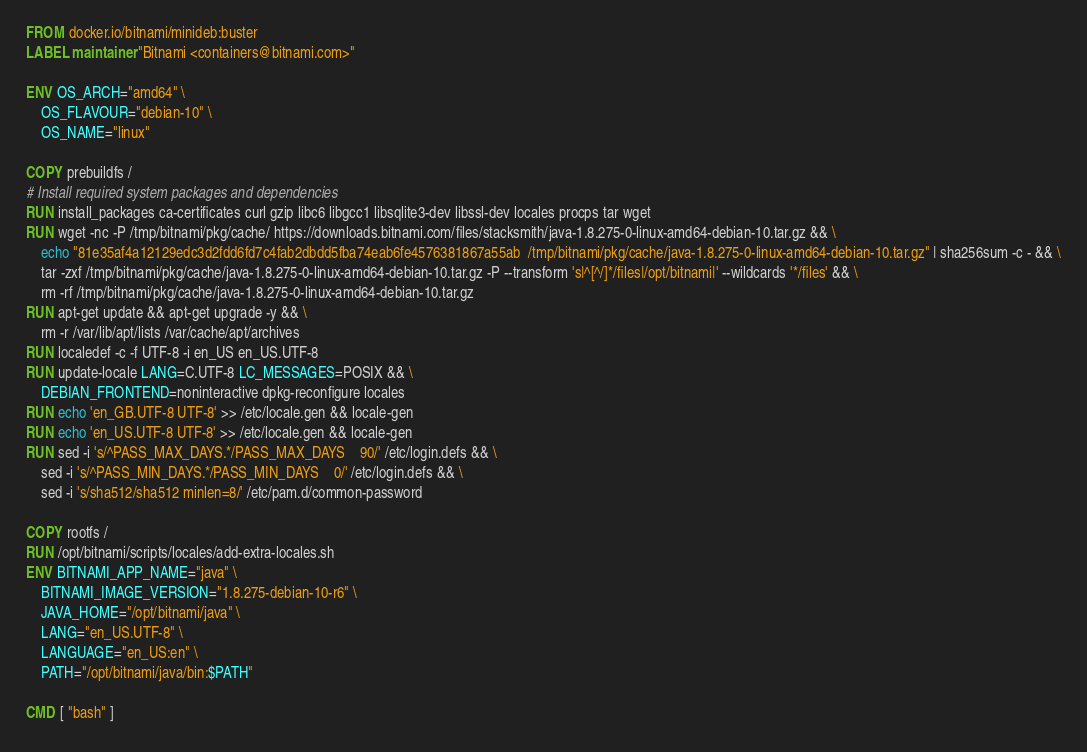<code> <loc_0><loc_0><loc_500><loc_500><_Dockerfile_>FROM docker.io/bitnami/minideb:buster
LABEL maintainer "Bitnami <containers@bitnami.com>"

ENV OS_ARCH="amd64" \
    OS_FLAVOUR="debian-10" \
    OS_NAME="linux"

COPY prebuildfs /
# Install required system packages and dependencies
RUN install_packages ca-certificates curl gzip libc6 libgcc1 libsqlite3-dev libssl-dev locales procps tar wget
RUN wget -nc -P /tmp/bitnami/pkg/cache/ https://downloads.bitnami.com/files/stacksmith/java-1.8.275-0-linux-amd64-debian-10.tar.gz && \
    echo "81e35af4a12129edc3d2fdd6fd7c4fab2dbdd5fba74eab6fe4576381867a55ab  /tmp/bitnami/pkg/cache/java-1.8.275-0-linux-amd64-debian-10.tar.gz" | sha256sum -c - && \
    tar -zxf /tmp/bitnami/pkg/cache/java-1.8.275-0-linux-amd64-debian-10.tar.gz -P --transform 's|^[^/]*/files|/opt/bitnami|' --wildcards '*/files' && \
    rm -rf /tmp/bitnami/pkg/cache/java-1.8.275-0-linux-amd64-debian-10.tar.gz
RUN apt-get update && apt-get upgrade -y && \
    rm -r /var/lib/apt/lists /var/cache/apt/archives
RUN localedef -c -f UTF-8 -i en_US en_US.UTF-8
RUN update-locale LANG=C.UTF-8 LC_MESSAGES=POSIX && \
    DEBIAN_FRONTEND=noninteractive dpkg-reconfigure locales
RUN echo 'en_GB.UTF-8 UTF-8' >> /etc/locale.gen && locale-gen
RUN echo 'en_US.UTF-8 UTF-8' >> /etc/locale.gen && locale-gen
RUN sed -i 's/^PASS_MAX_DAYS.*/PASS_MAX_DAYS    90/' /etc/login.defs && \
    sed -i 's/^PASS_MIN_DAYS.*/PASS_MIN_DAYS    0/' /etc/login.defs && \
    sed -i 's/sha512/sha512 minlen=8/' /etc/pam.d/common-password

COPY rootfs /
RUN /opt/bitnami/scripts/locales/add-extra-locales.sh
ENV BITNAMI_APP_NAME="java" \
    BITNAMI_IMAGE_VERSION="1.8.275-debian-10-r6" \
    JAVA_HOME="/opt/bitnami/java" \
    LANG="en_US.UTF-8" \
    LANGUAGE="en_US:en" \
    PATH="/opt/bitnami/java/bin:$PATH"

CMD [ "bash" ]
</code> 